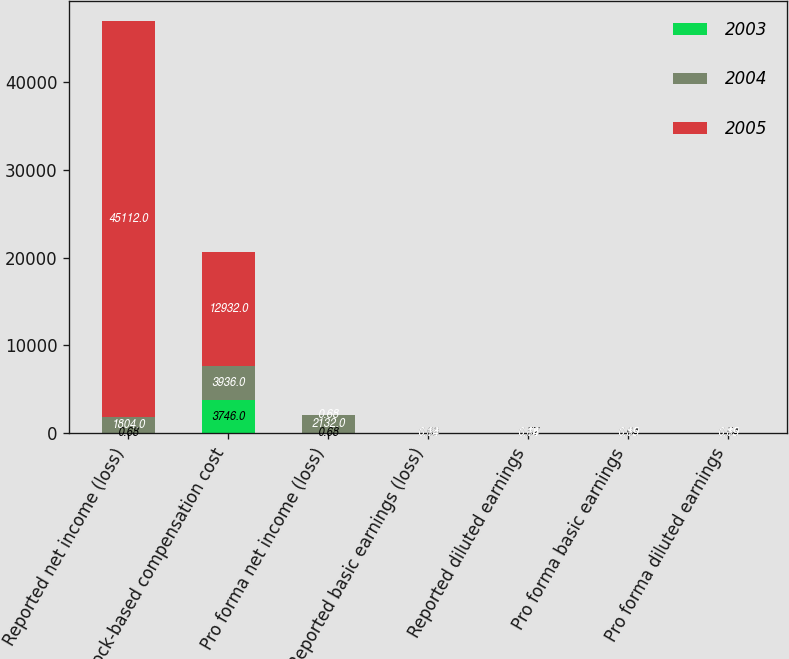Convert chart. <chart><loc_0><loc_0><loc_500><loc_500><stacked_bar_chart><ecel><fcel>Reported net income (loss)<fcel>Stock-based compensation cost<fcel>Pro forma net income (loss)<fcel>Reported basic earnings (loss)<fcel>Reported diluted earnings<fcel>Pro forma basic earnings<fcel>Pro forma diluted earnings<nl><fcel>2003<fcel>0.68<fcel>3746<fcel>0.68<fcel>0.68<fcel>0.57<fcel>0.64<fcel>0.54<nl><fcel>2004<fcel>1804<fcel>3936<fcel>2132<fcel>0.14<fcel>0.14<fcel>0.19<fcel>0.19<nl><fcel>2005<fcel>45112<fcel>12932<fcel>0.68<fcel>0.68<fcel>0.68<fcel>0.85<fcel>0.85<nl></chart> 